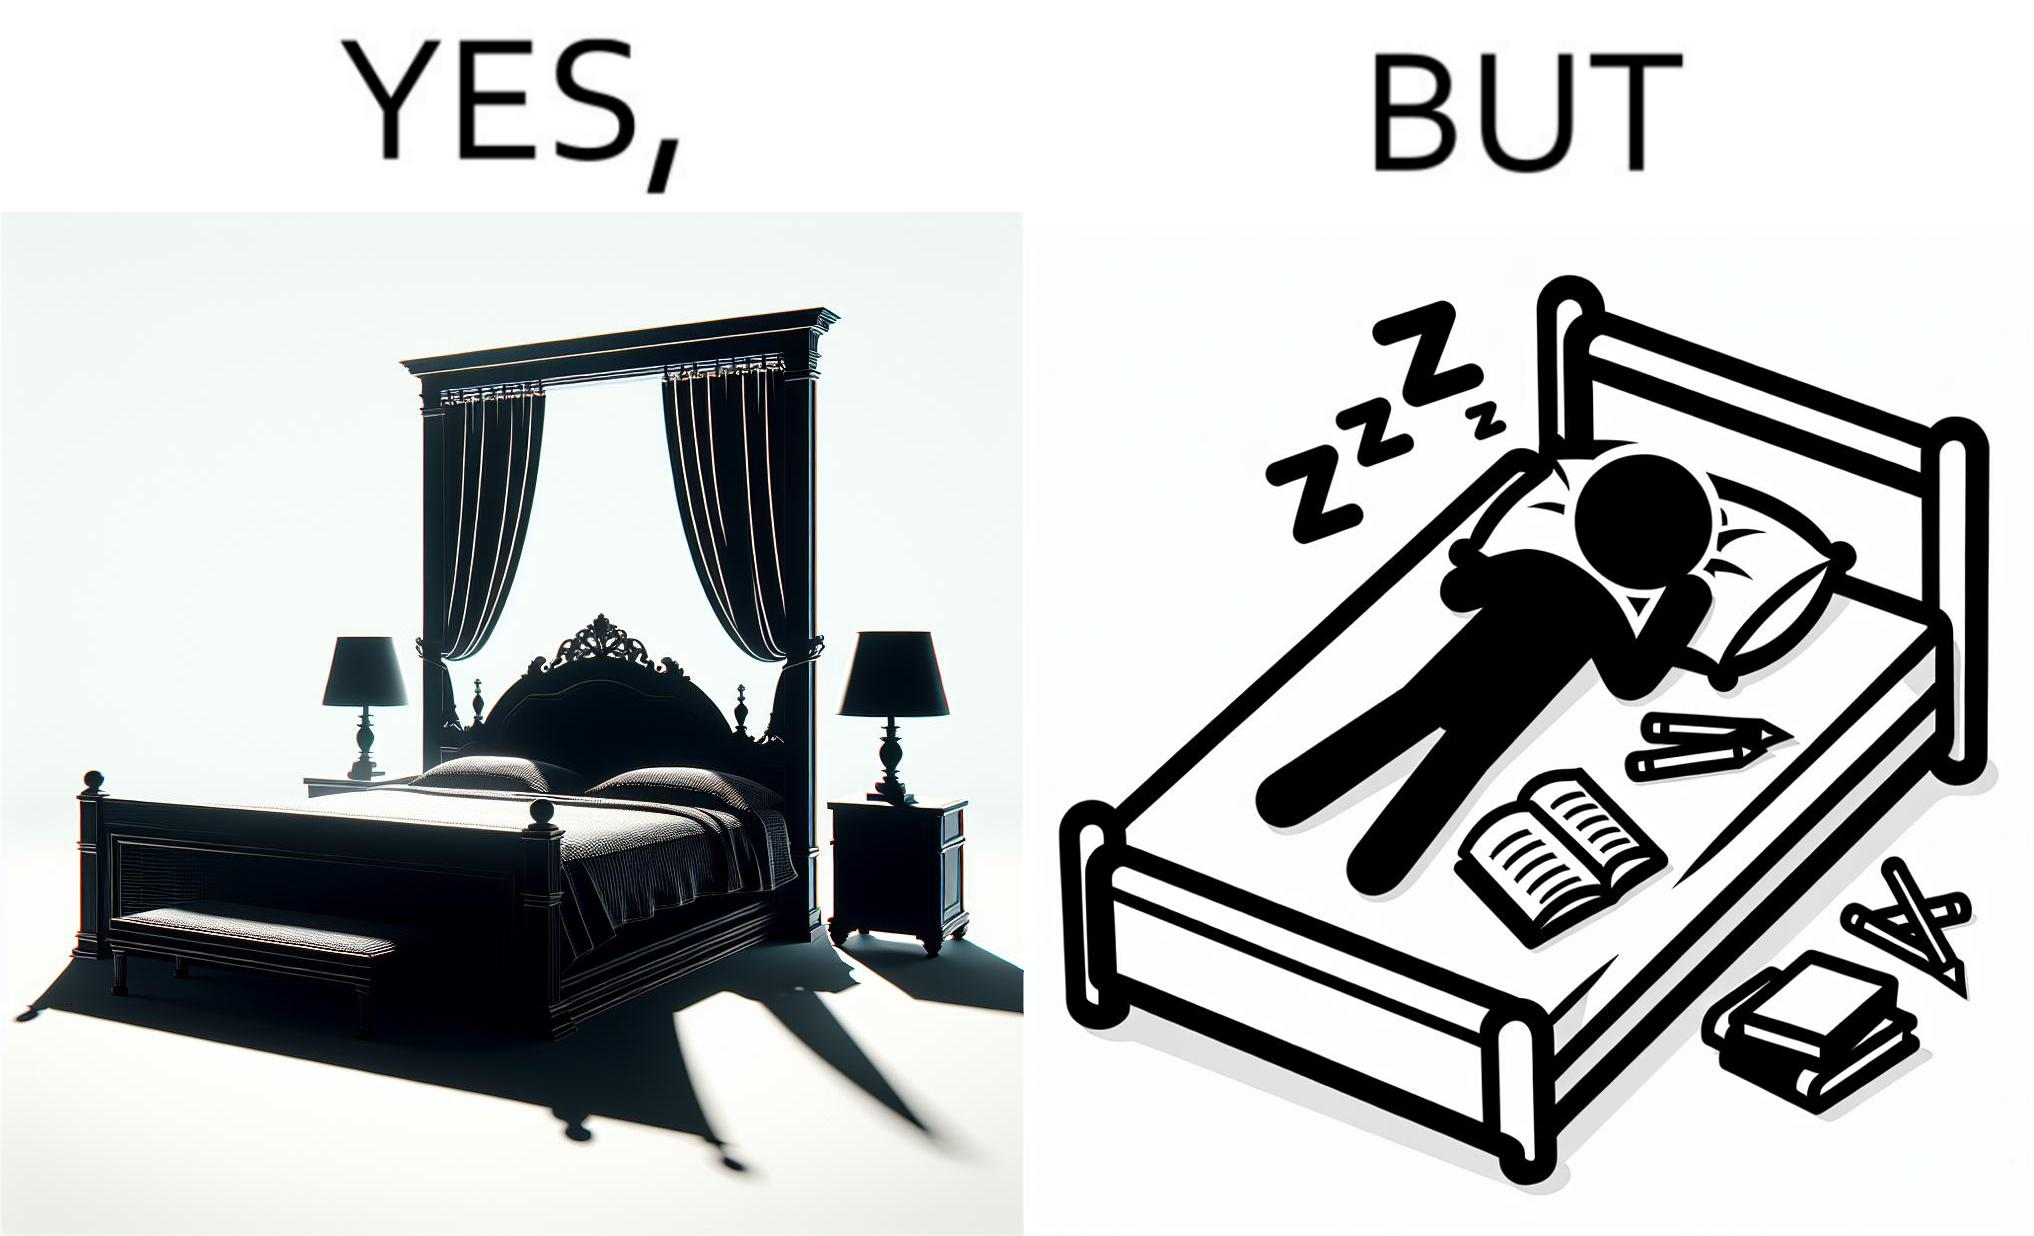Is this a satirical image? Yes, this image is satirical. 